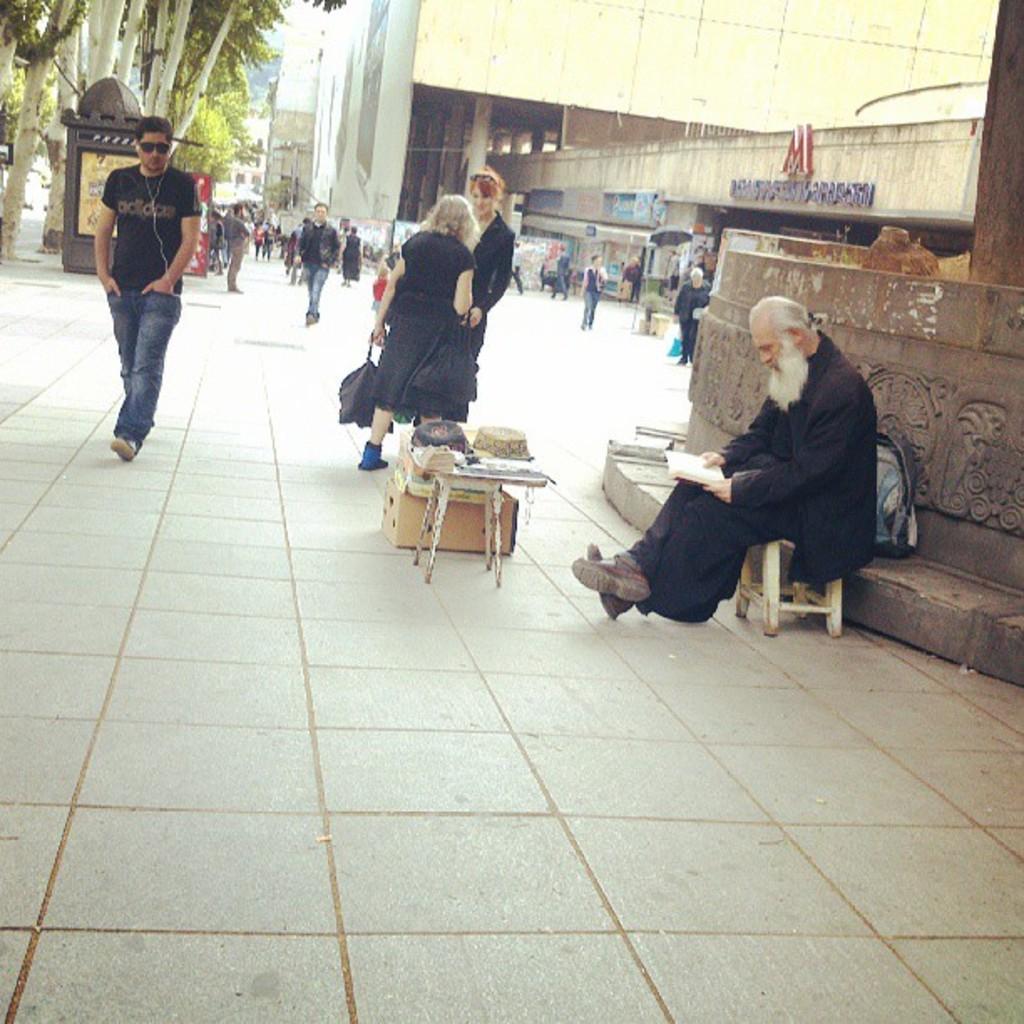Describe this image in one or two sentences. In this picture we can see some persons were some are walking, standing and sitting on stool and in front of this man we have table and on table we can see basket, papers and in the background we can see building, banners, trees. 